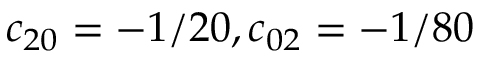Convert formula to latex. <formula><loc_0><loc_0><loc_500><loc_500>c _ { 2 0 } = - 1 / 2 0 , c _ { 0 2 } = - 1 / 8 0</formula> 